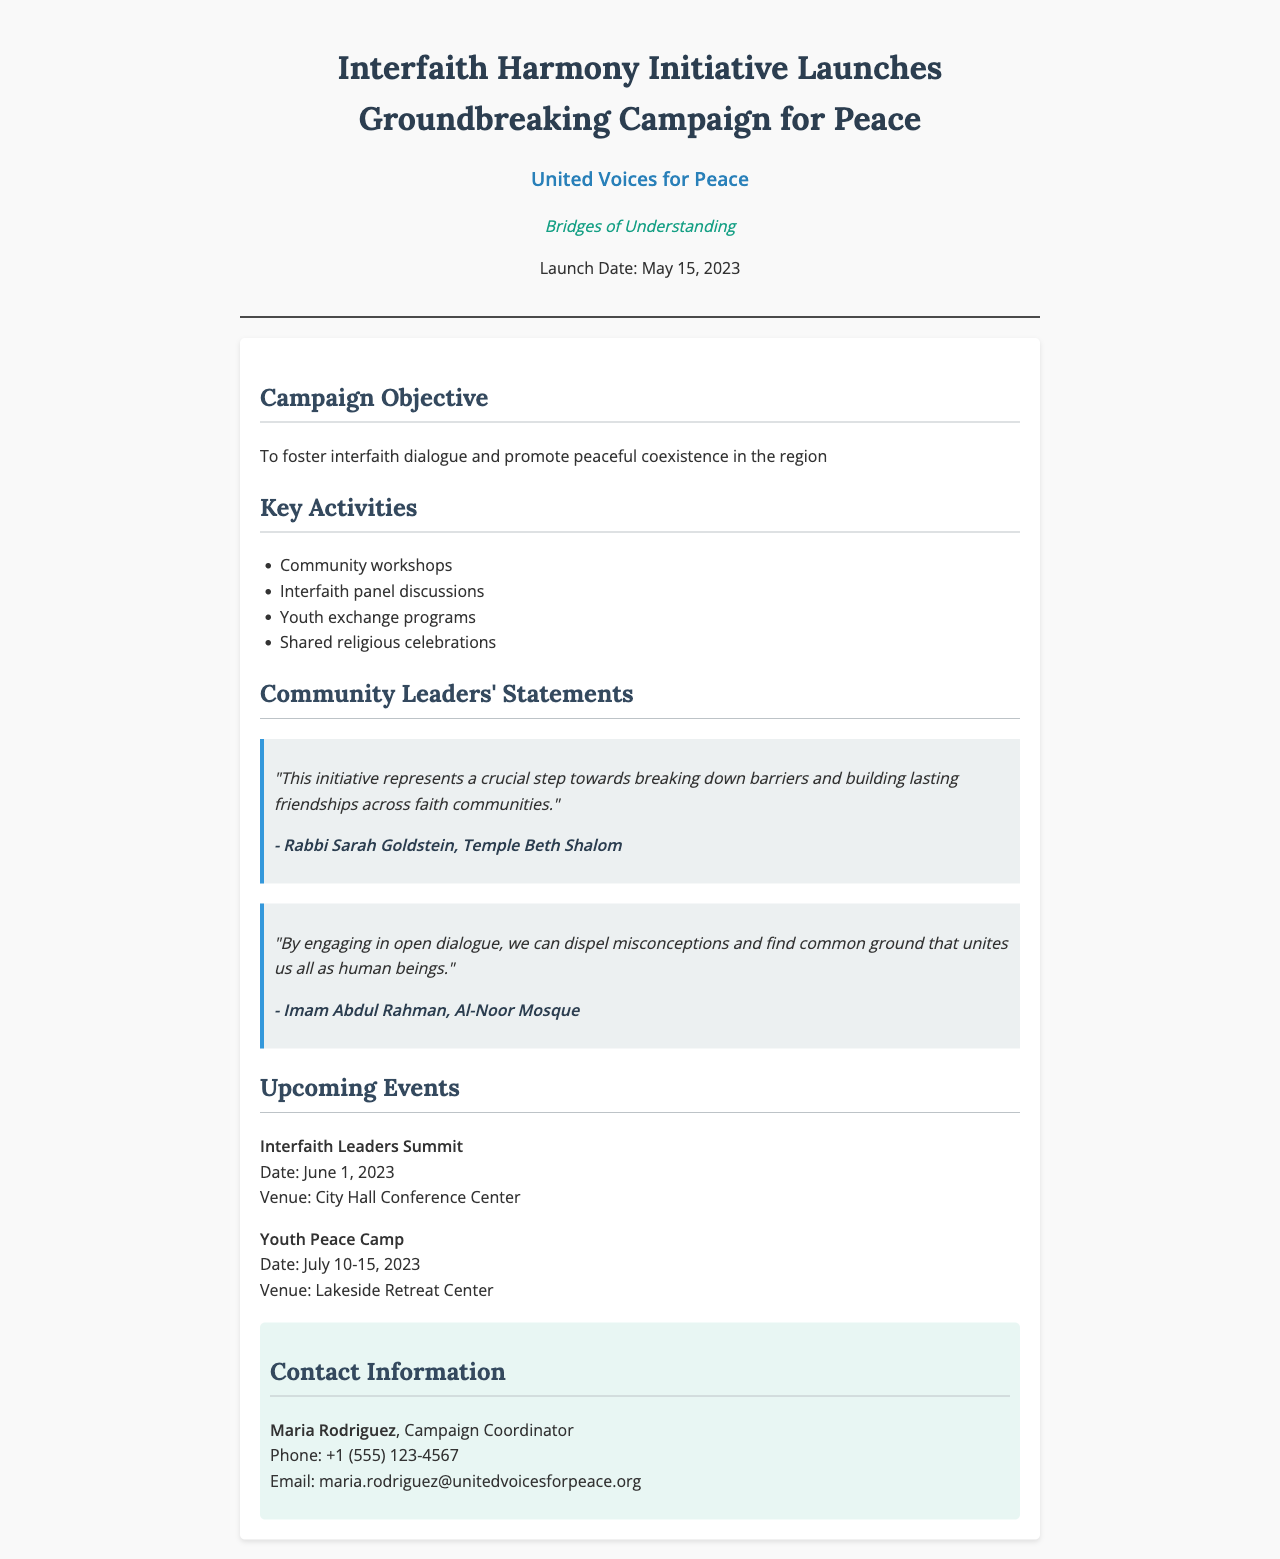what is the name of the campaign? The text explicitly mentions that the name of the campaign is "Bridges of Understanding."
Answer: Bridges of Understanding who is the campaign coordinator? The contact information section lists Maria Rodriguez as the campaign coordinator.
Answer: Maria Rodriguez when is the Interfaith Leaders Summit scheduled? The date for the Interfaith Leaders Summit is given as June 1, 2023.
Answer: June 1, 2023 what is one objective of the campaign? The document states that the campaign aims to foster interfaith dialogue and promote peaceful coexistence.
Answer: Foster interfaith dialogue who is quoted as saying the initiative is a crucial step? Rabbi Sarah Goldstein is quoted regarding the importance of the initiative.
Answer: Rabbi Sarah Goldstein how many key activities are listed? There are four key activities mentioned in the document.
Answer: four what will take place from July 10-15, 2023? The document states that a Youth Peace Camp is scheduled during that timeframe.
Answer: Youth Peace Camp what is the venue for the Youth Peace Camp? The venue for the Youth Peace Camp is identified as Lakeside Retreat Center.
Answer: Lakeside Retreat Center what type of document is this? The structure and content signify that this is a fax announcing a new campaign.
Answer: fax 